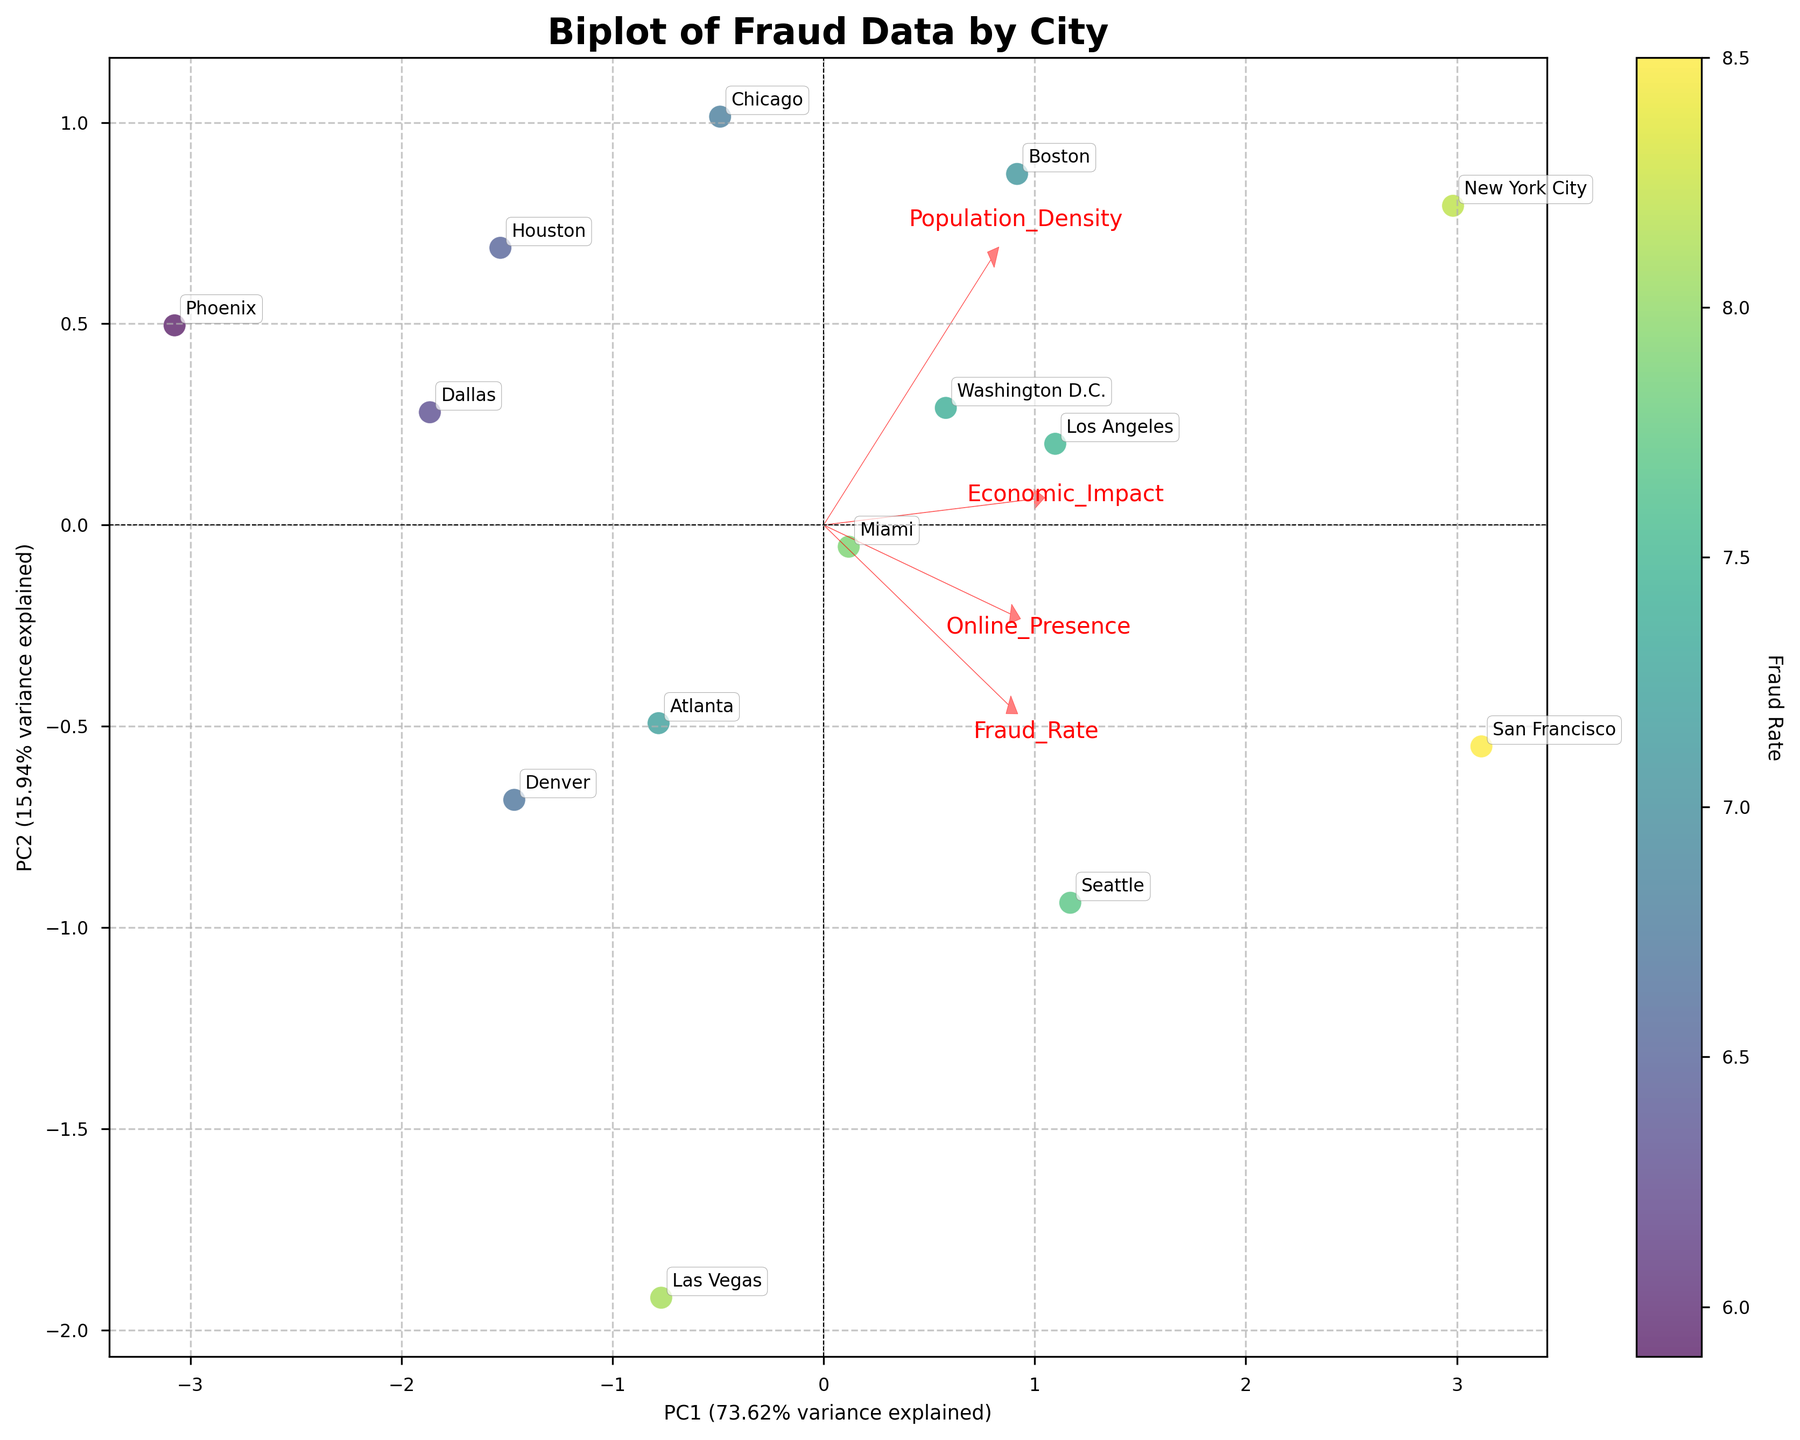What's the title of the plot? The title of the plot is displayed at the top and summarizes the main subject of the figure.
Answer: Biplot of Fraud Data by City What does the color bar represent? The color bar is generally used to indicate the variable that is color-coded in the scatter plot. From its placement next to the scatter points, we see it's labeled 'Fraud Rate'.
Answer: Fraud Rate How many cities are represented in the plot? Each point in the scatter plot represents a city, and cities are labeled next to the points. By counting these labels, we find the number of cities.
Answer: 14 Which city is associated with the highest Fraud Rate? By observing the scatter points and their respective colors, the city with the area in the darkest color indicates the highest Fraud Rate. This city is near the top right.
Answer: New York City Which two features have the most significant impact on PC1 and PC2, as shown by the arrows? The lengths of the arrows indicate the strength of the feature's impact. The longest arrows signify the most significant impact on the principal components.
Answer: Fraud Rate and Online Presence How much variance is explained by PC1? The variance explained by PC1 is shown on the x-axis label, expressed as a percentage value in parentheses.
Answer: 37.1% How are Miami and Boston positioned relative to PC1? By locating both Miami and Boston on the scatter plot, we can observe their positions concerning the x-axis. Miami is to the right, and Boston is close to the origins but positioned slightly to the right.
Answer: Both on the positive side Which feature is negatively correlated with PC1? Arrows pointing to the left (negative direction of the x-axis) indicate a negative correlation with PC1. By examining the direction of these loadings, we identify the feature.
Answer: Population Density Which two cities have a similar Fraud Rate, and what are their PC1 and PC2 scores? Observing the scatter points with similar colors helps identify cities with similar Fraud Rates. Reading their corresponding PC1 and PC2 positions from the plot provides complete information.
Answer: Seattle and Miami, with PC1 and PC2 scores close to (0.7, 0.9) and (1.3, 1.2) respectively How is the 'Online Presence' feature aligned relative to PC2? The direction and length of the 'Online Presence' arrow indicate its correlation with the vertical axis (PC2). By checking if it points upwards or downwards, we determine the correlation.
Answer: Positively 